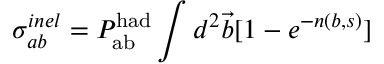Convert formula to latex. <formula><loc_0><loc_0><loc_500><loc_500>\sigma _ { a b } ^ { i n e l } = P _ { a b } ^ { h a d } \int d ^ { 2 } { \vec { b } } [ 1 - e ^ { - n ( b , s ) } ]</formula> 